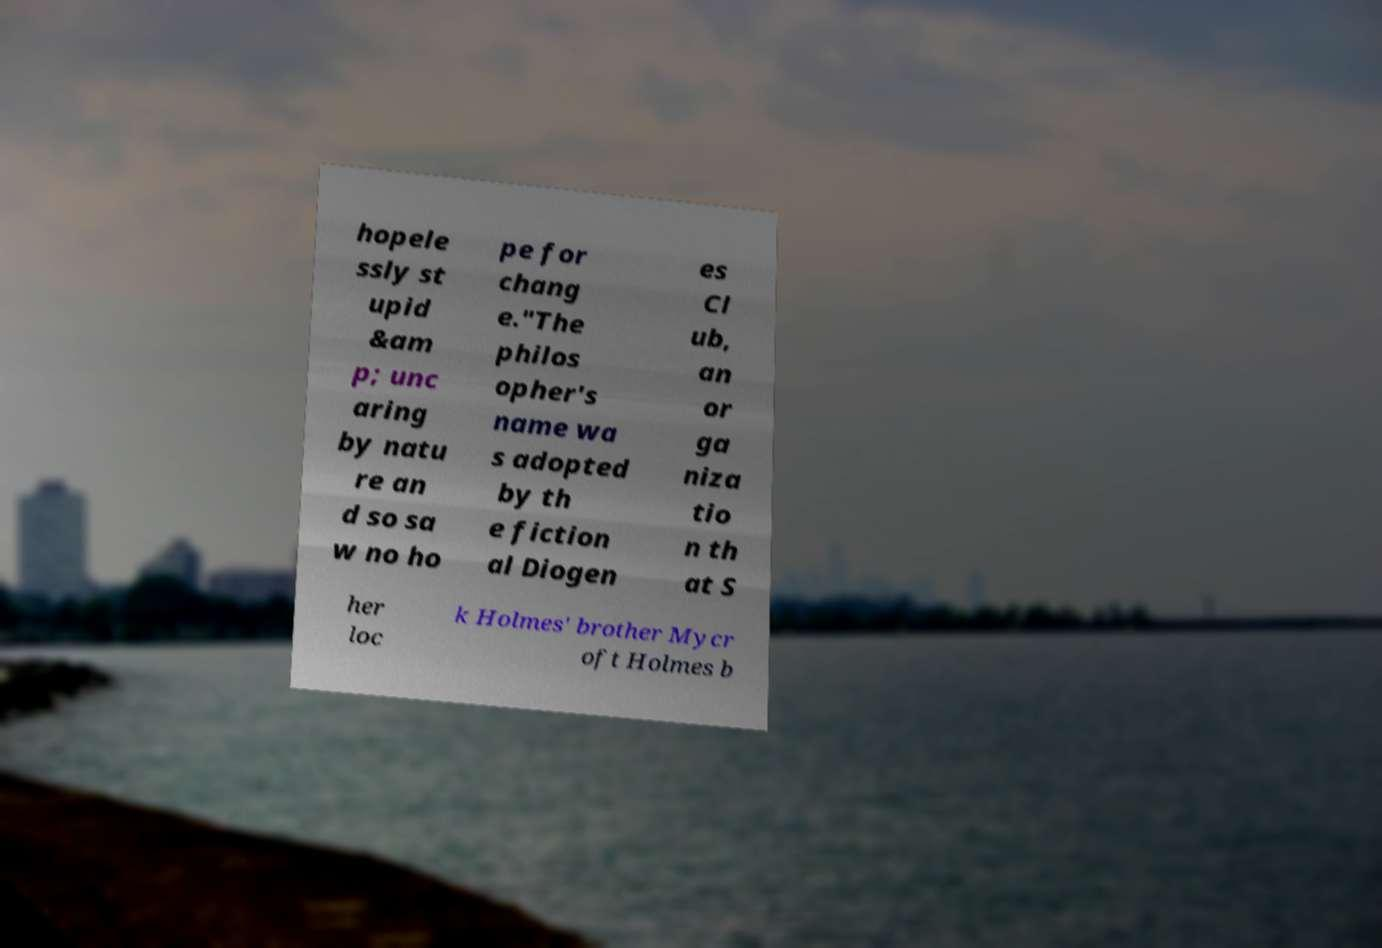Can you accurately transcribe the text from the provided image for me? hopele ssly st upid &am p; unc aring by natu re an d so sa w no ho pe for chang e."The philos opher's name wa s adopted by th e fiction al Diogen es Cl ub, an or ga niza tio n th at S her loc k Holmes' brother Mycr oft Holmes b 